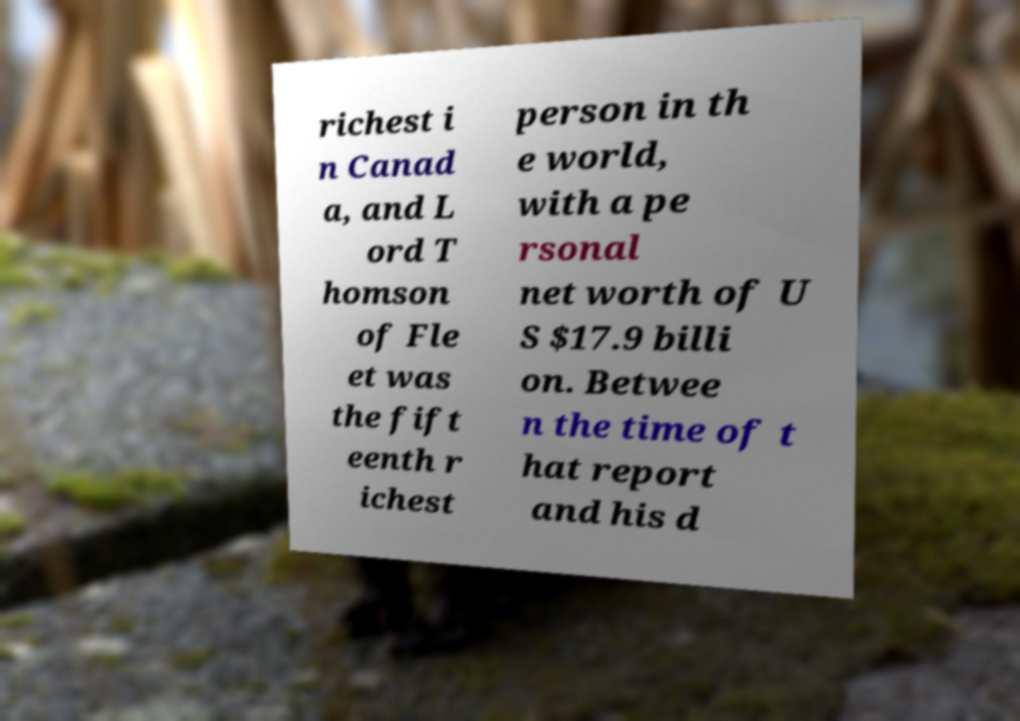What messages or text are displayed in this image? I need them in a readable, typed format. richest i n Canad a, and L ord T homson of Fle et was the fift eenth r ichest person in th e world, with a pe rsonal net worth of U S $17.9 billi on. Betwee n the time of t hat report and his d 